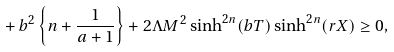Convert formula to latex. <formula><loc_0><loc_0><loc_500><loc_500>+ \, b ^ { 2 } \left \{ n + \frac { 1 } { a + 1 } \right \} + 2 \Lambda M ^ { 2 } \sinh ^ { 2 n } ( b T ) \sinh ^ { 2 n } ( r X ) \geq 0 ,</formula> 